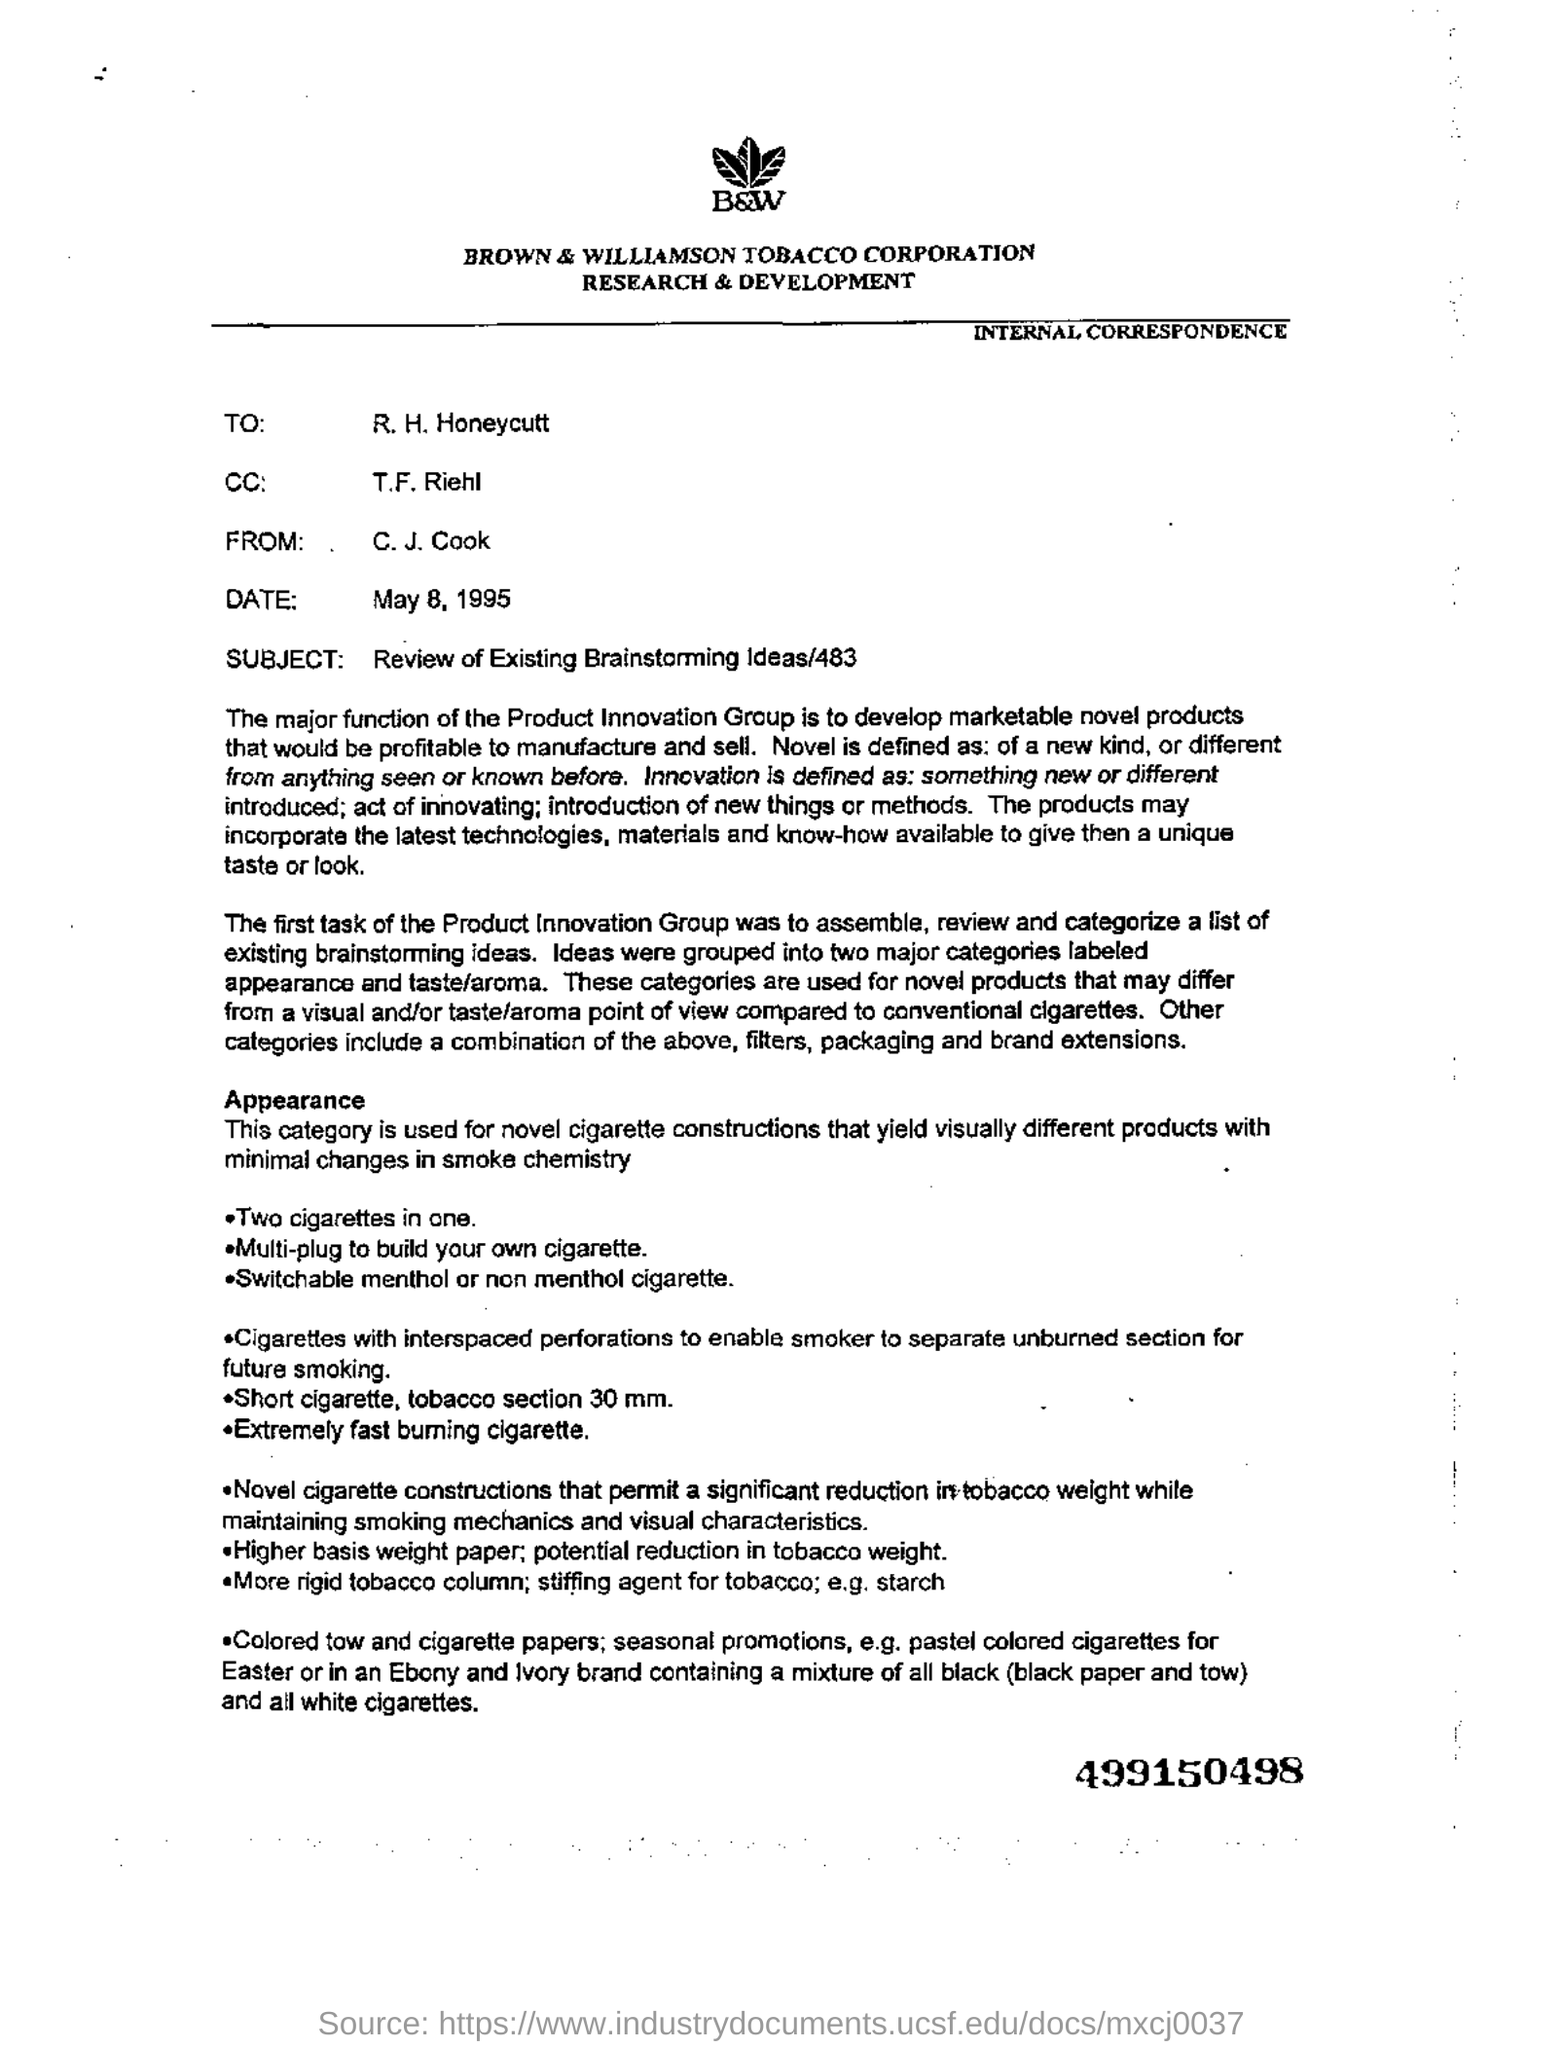Which corporation's letterhead is this?
Your answer should be very brief. Brown & Williamson Tobacco Corporation. Who is in  cc in this letter?
Your response must be concise. T.F. Riehl. What is the subject of  this letter?
Offer a very short reply. Review of existing Brainstorming Ideas/483. What is the number at the bottom of the page, in bold?
Your answer should be very brief. 499150498. What is written below the logo which looks like three leaves?
Give a very brief answer. B&W. 